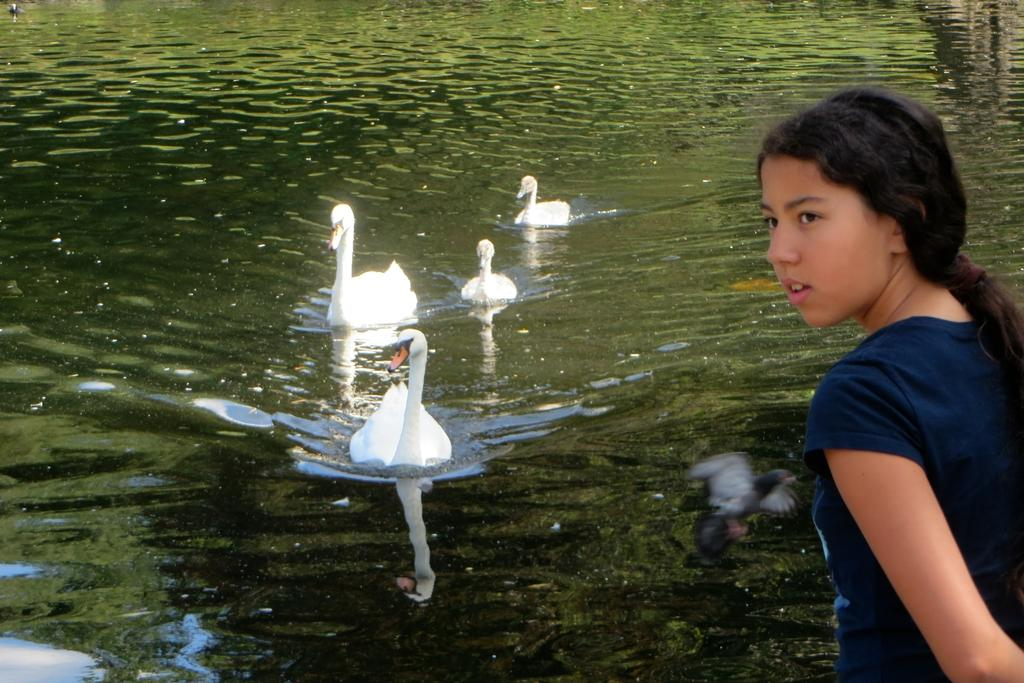What type of animals can be seen in the water in the image? There are swans and ducks in the water in the image. Are the swans and ducks moving in the image? Yes, the swans and ducks are moving in the image. Can you describe the woman's position in the image? The woman is standing on the right side of the image. What else is happening in the image besides the swans, ducks, and woman? There is a bird flying in the image. What type of experience does the woman have with sailing a ship in the image? There is no ship present in the image, and therefore no experience with sailing can be observed. 